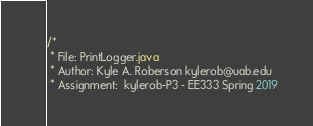<code> <loc_0><loc_0><loc_500><loc_500><_Java_>/*
 * File: PrintLogger.java
 * Author: Kyle A. Roberson kylerob@uab.edu
 * Assignment:  kylerob-P3 - EE333 Spring 2019</code> 